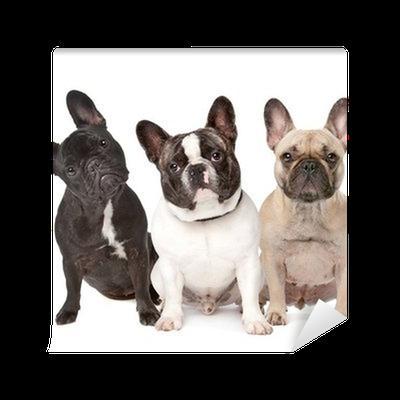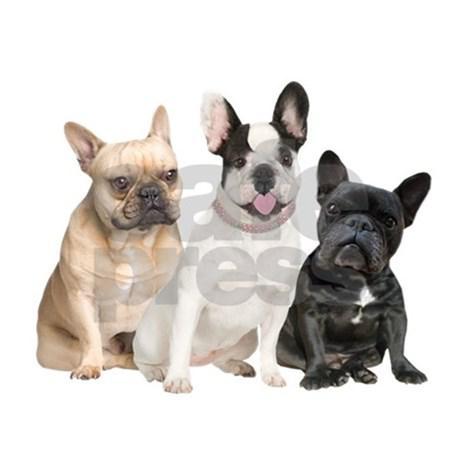The first image is the image on the left, the second image is the image on the right. Considering the images on both sides, is "One of the images features three dogs with their front limbs draped over a horizontal edge." valid? Answer yes or no. No. The first image is the image on the left, the second image is the image on the right. Examine the images to the left and right. Is the description "Each image shows a horizontal row of three flat-faced dogs, and the right image shows the dogs leaning on a white ledge." accurate? Answer yes or no. No. 